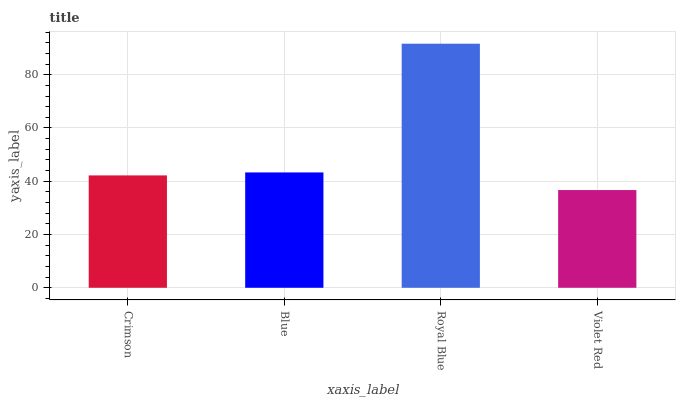Is Blue the minimum?
Answer yes or no. No. Is Blue the maximum?
Answer yes or no. No. Is Blue greater than Crimson?
Answer yes or no. Yes. Is Crimson less than Blue?
Answer yes or no. Yes. Is Crimson greater than Blue?
Answer yes or no. No. Is Blue less than Crimson?
Answer yes or no. No. Is Blue the high median?
Answer yes or no. Yes. Is Crimson the low median?
Answer yes or no. Yes. Is Royal Blue the high median?
Answer yes or no. No. Is Royal Blue the low median?
Answer yes or no. No. 